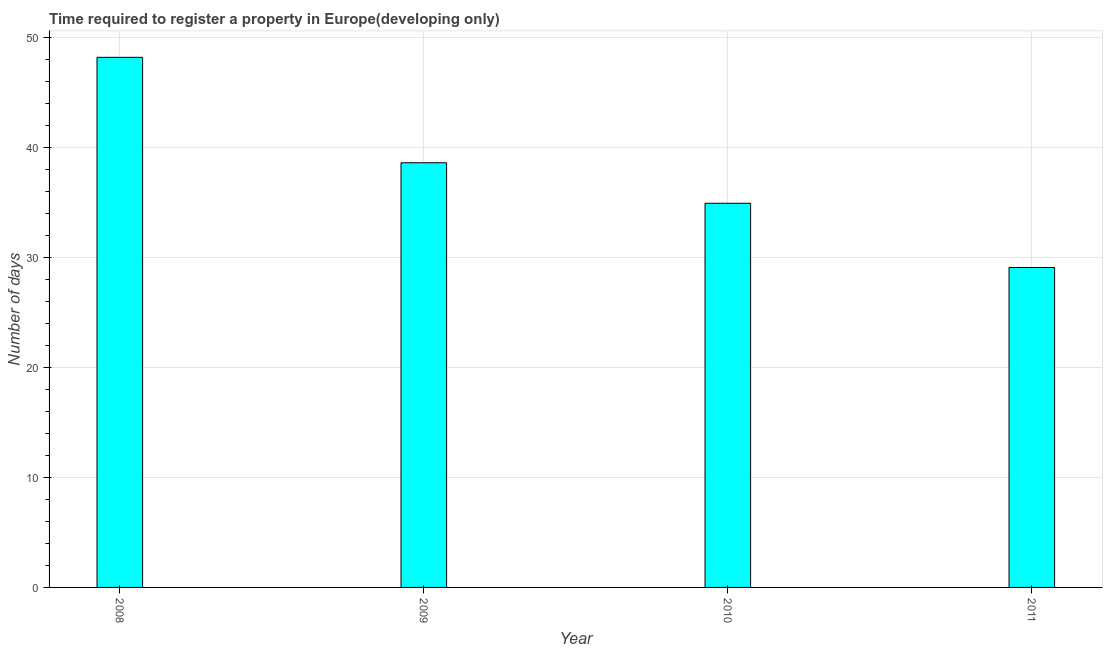What is the title of the graph?
Ensure brevity in your answer.  Time required to register a property in Europe(developing only). What is the label or title of the X-axis?
Offer a very short reply. Year. What is the label or title of the Y-axis?
Make the answer very short. Number of days. What is the number of days required to register property in 2010?
Offer a very short reply. 34.95. Across all years, what is the maximum number of days required to register property?
Keep it short and to the point. 48.22. Across all years, what is the minimum number of days required to register property?
Provide a succinct answer. 29.11. In which year was the number of days required to register property maximum?
Offer a terse response. 2008. In which year was the number of days required to register property minimum?
Your response must be concise. 2011. What is the sum of the number of days required to register property?
Give a very brief answer. 150.91. What is the difference between the number of days required to register property in 2008 and 2010?
Offer a terse response. 13.28. What is the average number of days required to register property per year?
Keep it short and to the point. 37.73. What is the median number of days required to register property?
Make the answer very short. 36.79. In how many years, is the number of days required to register property greater than 46 days?
Keep it short and to the point. 1. Do a majority of the years between 2008 and 2011 (inclusive) have number of days required to register property greater than 18 days?
Provide a succinct answer. Yes. What is the ratio of the number of days required to register property in 2009 to that in 2011?
Provide a short and direct response. 1.33. What is the difference between the highest and the second highest number of days required to register property?
Ensure brevity in your answer.  9.59. What is the difference between the highest and the lowest number of days required to register property?
Your response must be concise. 19.12. How many bars are there?
Your response must be concise. 4. Are all the bars in the graph horizontal?
Your answer should be compact. No. How many years are there in the graph?
Provide a succinct answer. 4. What is the Number of days in 2008?
Give a very brief answer. 48.22. What is the Number of days in 2009?
Give a very brief answer. 38.63. What is the Number of days in 2010?
Provide a short and direct response. 34.95. What is the Number of days in 2011?
Your answer should be compact. 29.11. What is the difference between the Number of days in 2008 and 2009?
Your answer should be very brief. 9.59. What is the difference between the Number of days in 2008 and 2010?
Make the answer very short. 13.27. What is the difference between the Number of days in 2008 and 2011?
Ensure brevity in your answer.  19.12. What is the difference between the Number of days in 2009 and 2010?
Your response must be concise. 3.68. What is the difference between the Number of days in 2009 and 2011?
Your response must be concise. 9.53. What is the difference between the Number of days in 2010 and 2011?
Your answer should be very brief. 5.84. What is the ratio of the Number of days in 2008 to that in 2009?
Provide a short and direct response. 1.25. What is the ratio of the Number of days in 2008 to that in 2010?
Provide a short and direct response. 1.38. What is the ratio of the Number of days in 2008 to that in 2011?
Your answer should be compact. 1.66. What is the ratio of the Number of days in 2009 to that in 2010?
Offer a very short reply. 1.1. What is the ratio of the Number of days in 2009 to that in 2011?
Keep it short and to the point. 1.33. What is the ratio of the Number of days in 2010 to that in 2011?
Provide a short and direct response. 1.2. 